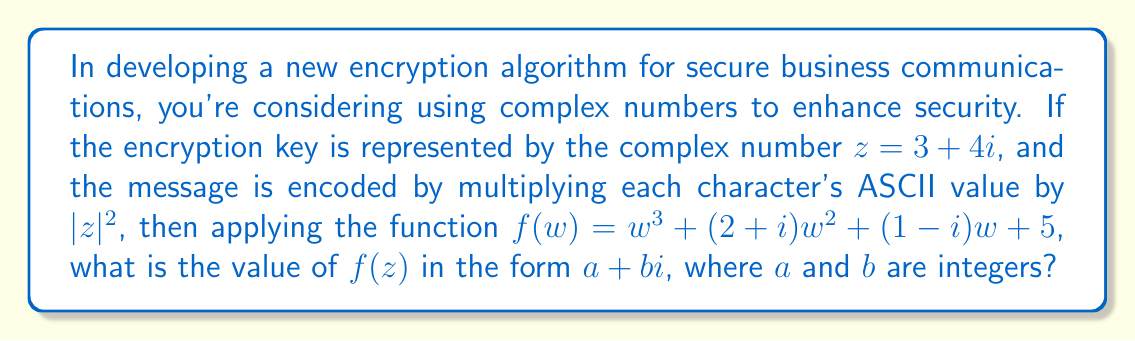Can you answer this question? Let's approach this step-by-step:

1) First, we need to calculate $|z|^2$:
   $|z|^2 = (3^2 + 4^2) = 9 + 16 = 25$

2) Now, we need to calculate $f(z)$. Let's break it down term by term:

   a) $z^3 = (3+4i)^3 = 27 + 108i - 108 - 64i = -81 + 44i$

   b) $(2+i)z^2$:
      $z^2 = (3+4i)^2 = 9 + 24i - 16 = -7 + 24i$
      $(2+i)(-7+24i) = -14 + 48i + (-7i + 24i^2) = -38 + 41i$

   c) $(1-i)z$:
      $(1-i)(3+4i) = 3 + 4i - 3i - 4i^2 = 7 + i$

   d) The constant term: 5

3) Now, let's add all these terms:
   $f(z) = (-81 + 44i) + (-38 + 41i) + (7 + i) + 5$
   $f(z) = -107 + 86i$

Therefore, $f(z) = -107 + 86i$, where $a = -107$ and $b = 86$.
Answer: $-107 + 86i$ 